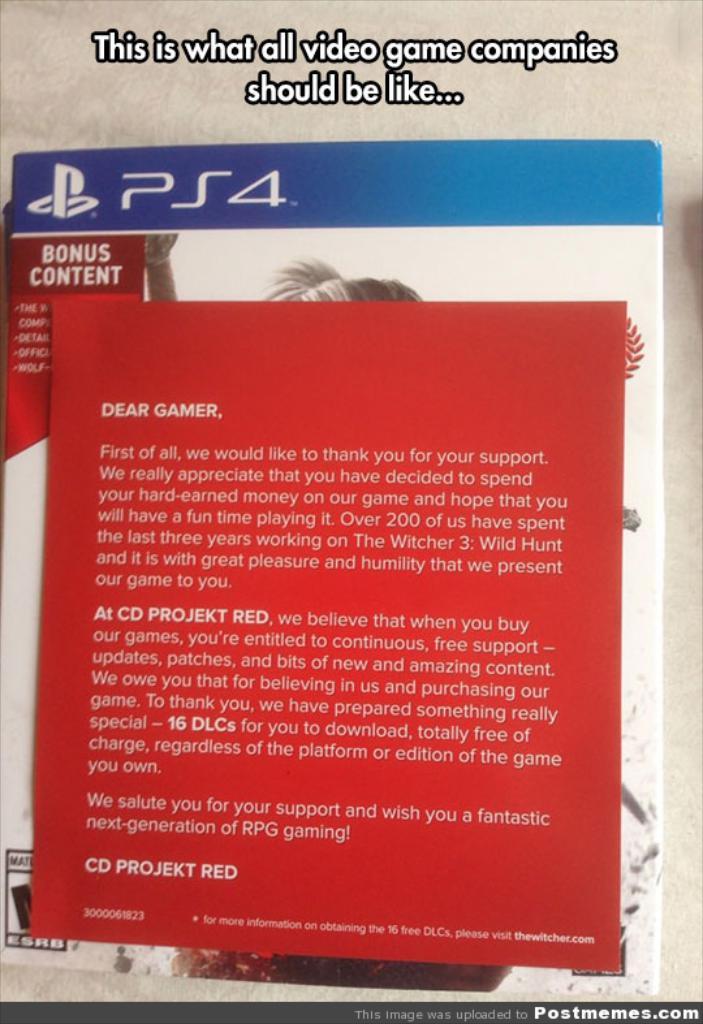What gaming system is this for?
Offer a terse response. Ps4. 